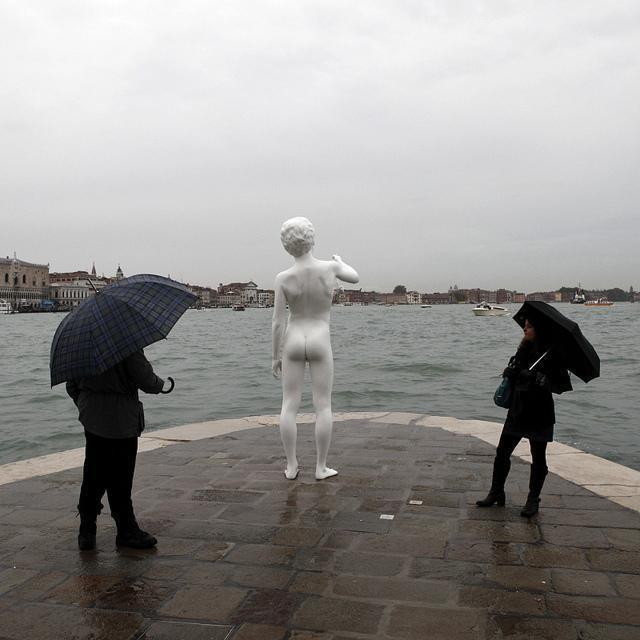How many people are there?
Give a very brief answer. 2. How many people are in the photo?
Give a very brief answer. 2. How many umbrellas are there?
Give a very brief answer. 2. How many person is wearing orange color t-shirt?
Give a very brief answer. 0. 